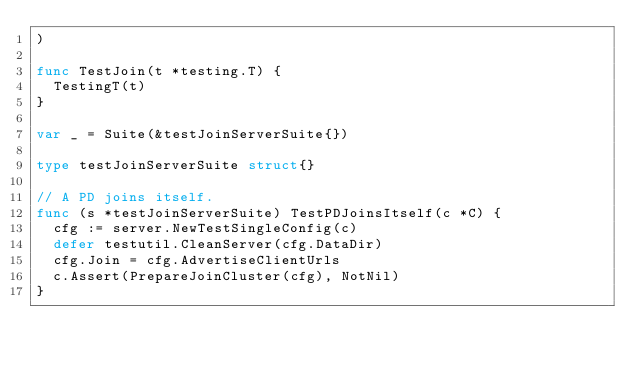Convert code to text. <code><loc_0><loc_0><loc_500><loc_500><_Go_>)

func TestJoin(t *testing.T) {
	TestingT(t)
}

var _ = Suite(&testJoinServerSuite{})

type testJoinServerSuite struct{}

// A PD joins itself.
func (s *testJoinServerSuite) TestPDJoinsItself(c *C) {
	cfg := server.NewTestSingleConfig(c)
	defer testutil.CleanServer(cfg.DataDir)
	cfg.Join = cfg.AdvertiseClientUrls
	c.Assert(PrepareJoinCluster(cfg), NotNil)
}
</code> 